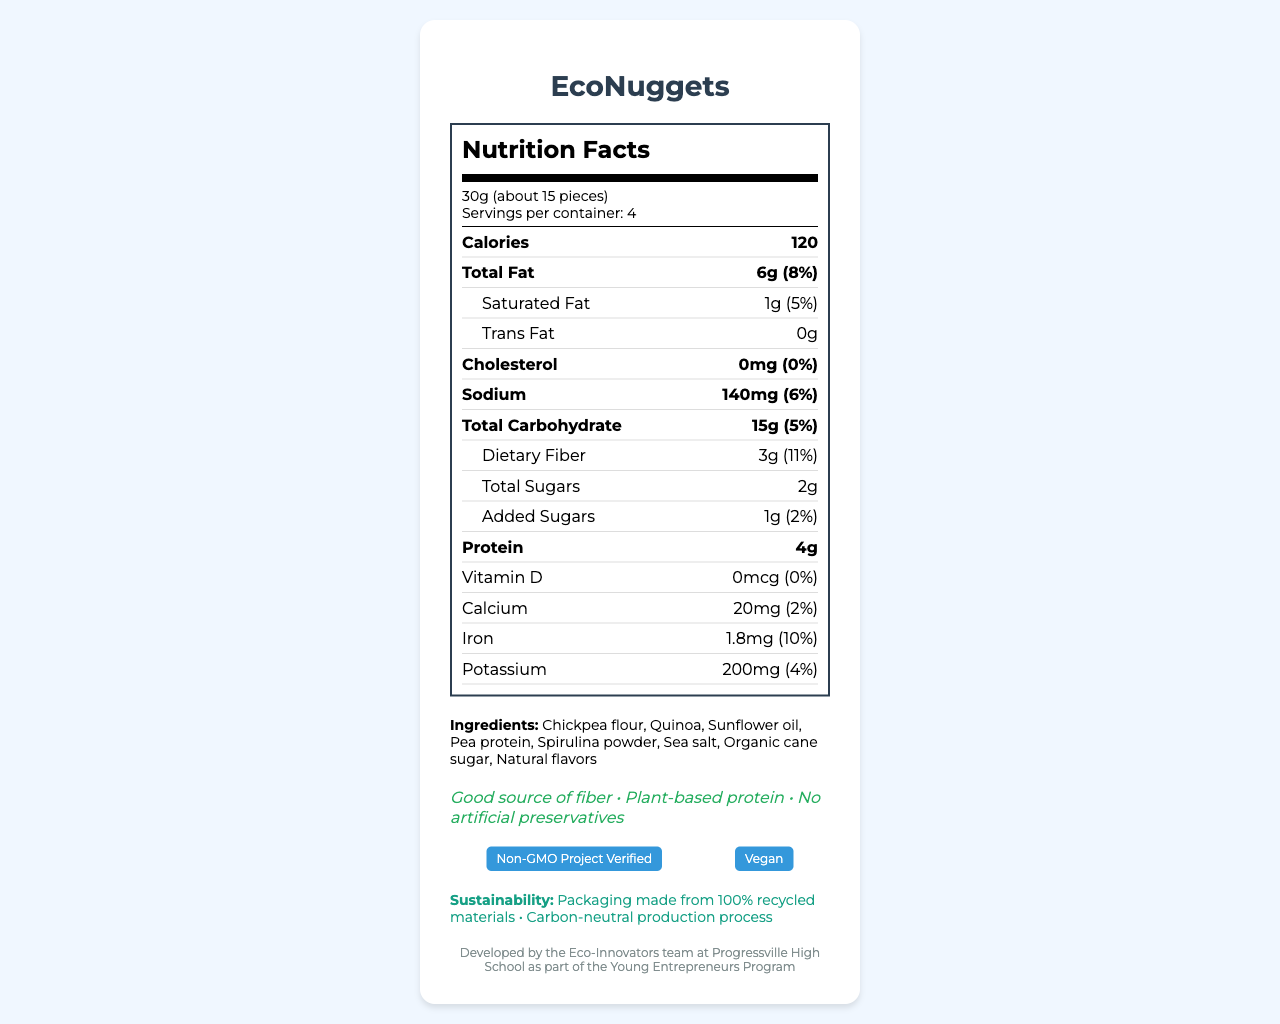what is the product name? The product name is mentioned at the top of the document under the title "Nutrition Facts: EcoNuggets".
Answer: EcoNuggets how many servings are in each container? The document states "Servings per container: 4".
Answer: 4 servings how many calories are there per serving? The number of calories per serving is listed as 120 in the nutrition label section.
Answer: 120 calories what is the amount of dietary fiber per serving? The dietary fiber amount per serving is listed as 3g in the nutrition information.
Answer: 3g which ingredient is listed first? The ingredients are listed in order, and chickpea flour is the first ingredient.
Answer: Chickpea flour how much total fat is in one serving of EcoNuggets? The total fat per serving is specified as 6g in the nutrition information.
Answer: 6g what is the percentage daily value of iron per serving? The daily value percentage for iron per serving is 10%.
Answer: 10% how many certifications does the product have? The document lists two certifications: "Non-GMO Project Verified" and "Vegan".
Answer: 2 certifications is the product vegan? One of the certifications mentioned is "Vegan", confirming the product is vegan.
Answer: Yes is there any cholesterol in EcoNuggets? The nutrition information states that EcoNuggets have 0mg of cholesterol.
Answer: No how much sodium does one serving contain? The amount of sodium per serving is listed as 140mg.
Answer: 140mg what is the name of the company that produces EcoNuggets? The company info section lists the name as Green Sprout Foods.
Answer: Green Sprout Foods what is the serving size of EcoNuggets? The serving size is listed as 30g (about 15 pieces).
Answer: 30g (about 15 pieces) where is the company Green Sprout Foods located? The company address is mentioned as 123 Innovation Way, Progressville, CA 90210.
Answer: 123 Innovation Way, Progressville, CA 90210 which of the following is NOT an ingredient in EcoNuggets? A. Quinoa B. Pea protein C. Wheat flour D. Sunflower oil The ingredients list includes Quinoa, Pea protein, and Sunflower oil but not Wheat flour.
Answer: C. Wheat flour which of the following is a health claim made about EcoNuggets? I. Good source of fiber II. Low in sodium III. Plant-based protein IV. No artificial preservatives The health claims listed are "Good source of fiber", "Plant-based protein", and "No artificial preservatives", but not "Low in sodium".
Answer: II. Low in sodium is there any vitamin D in EcoNuggets? The nutrition information states there is 0mcg of vitamin D per serving.
Answer: No what are the sustainability features of the product? The sustainability features listed are "Packaging made from 100% recycled materials" and "Carbon-neutral production process".
Answer: Packaging made from 100% recycled materials, Carbon-neutral production process what is the main idea of the document? The document includes sections on nutritional facts, ingredients, health claims, certifications, company and product information, sustainability features, and student project details, offering a comprehensive overview of EcoNuggets.
Answer: The document provides detailed nutritional information, ingredients, certifications, health claims, and sustainability features of EcoNuggets, a plant-based snack developed by students as part of an entrepreneurship project. how much saturated fat and trans fat are in one serving? The nutrition information lists 1g of saturated fat and 0g of trans fat per serving.
Answer: 1g of saturated fat and 0g of trans fat who developed EcoNuggets? The document states that EcoNuggets were developed by the Eco-Innovators team at Progressville High School as part of the Young Entrepreneurs Program.
Answer: Eco-Innovators team at Progressville High School how much protein is in a single serving? The nutrition label indicates that each serving contains 4g of protein.
Answer: 4g what is the daily value percentage of calcium in one serving? The daily value percentage of calcium per serving is 2%.
Answer: 2% does the product contain any added sugars? The nutrition label indicates that there is 1g of added sugars per serving.
Answer: Yes are EcoNuggets free of artificial preservatives? One of the health claims is "No artificial preservatives", indicating that EcoNuggets are free of such preservatives.
Answer: Yes how many grains of spirulina powder are in each serving? The document lists spirulina powder as an ingredient but does not specify the exact quantity per serving.
Answer: Not enough information 